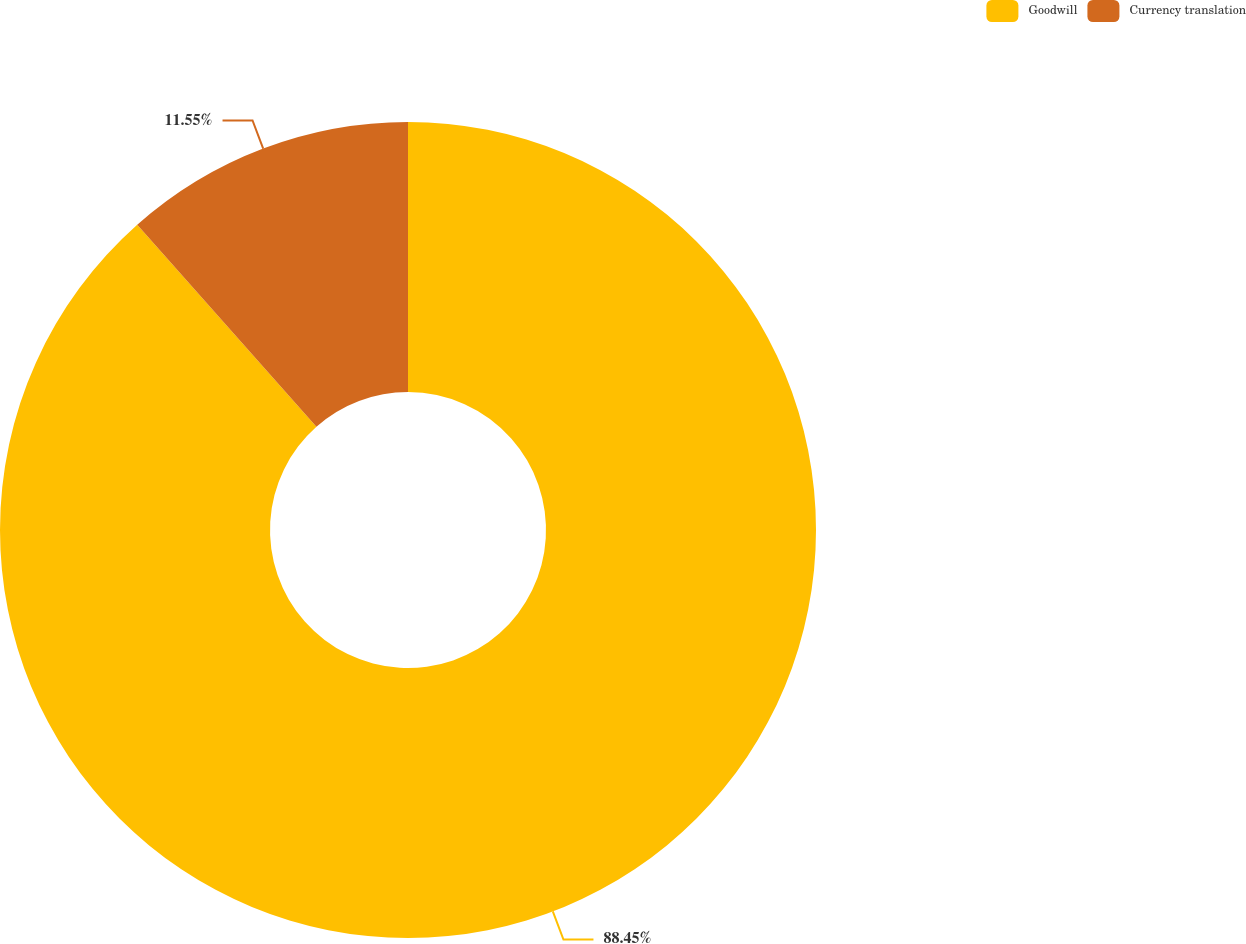Convert chart. <chart><loc_0><loc_0><loc_500><loc_500><pie_chart><fcel>Goodwill<fcel>Currency translation<nl><fcel>88.45%<fcel>11.55%<nl></chart> 